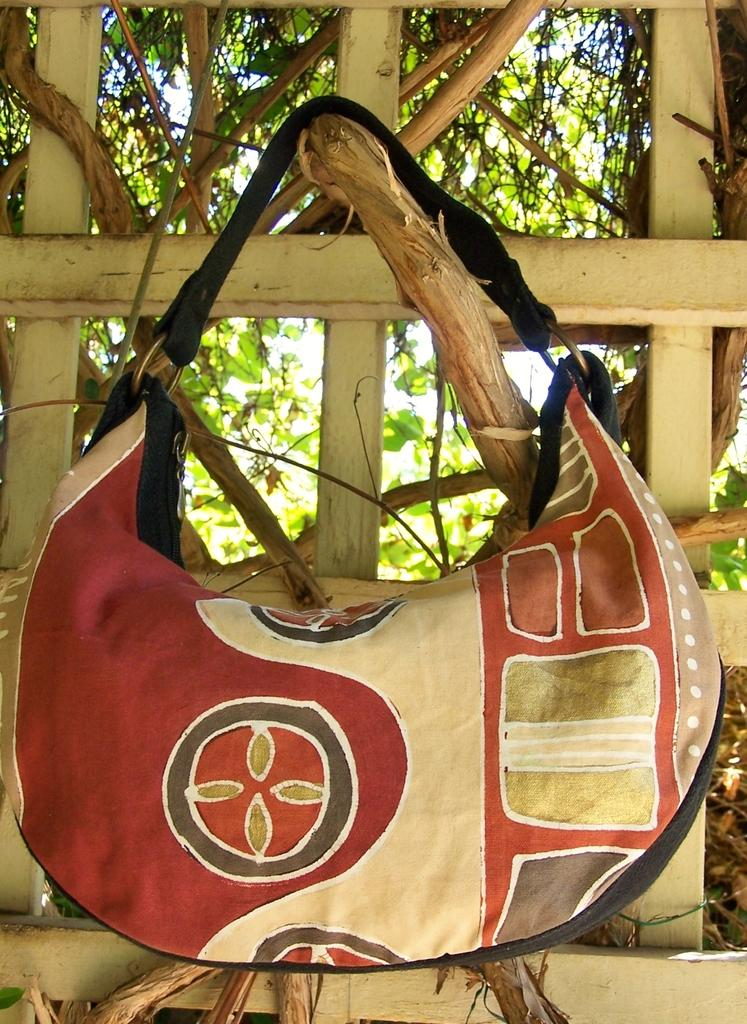What object is hanging in the image? There is a bag in the image. How is the bag suspended in the image? The bag is hanged on a creeper. What type of thread is used to create the stage in the image? There is no stage present in the image, so there is no thread used for it. 